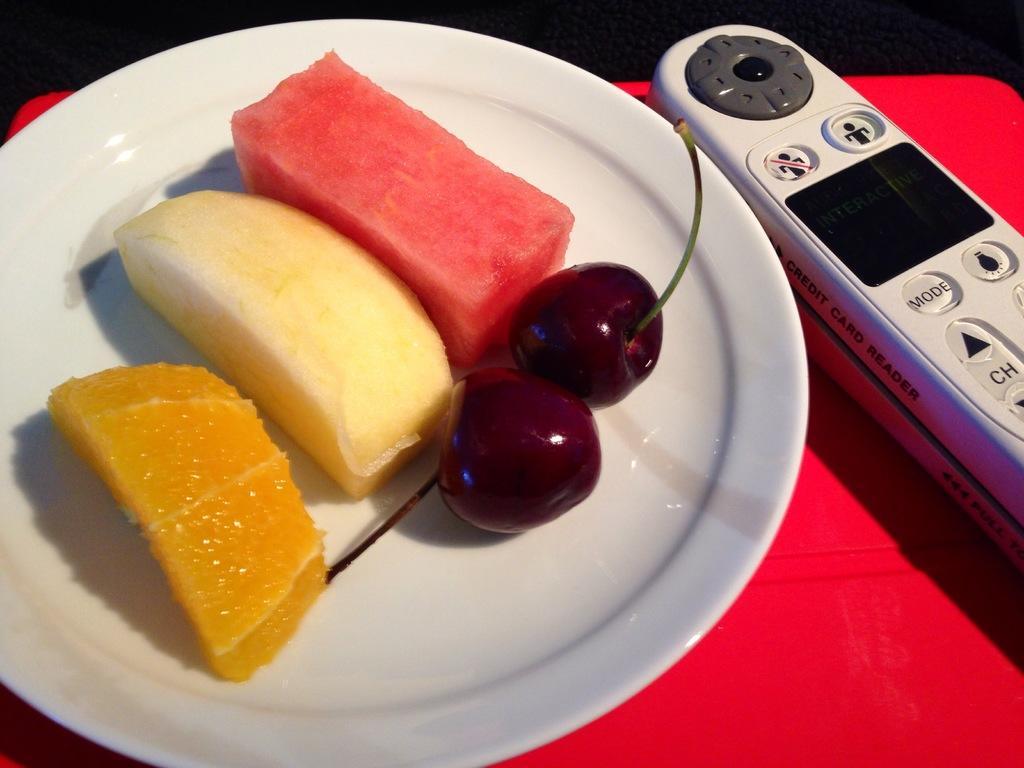Can you describe this image briefly? In the picture I can see two berries and few more fruits are cut and kept on the white color plate. Here we can see a remote controller and they are placed on the red color surface. 